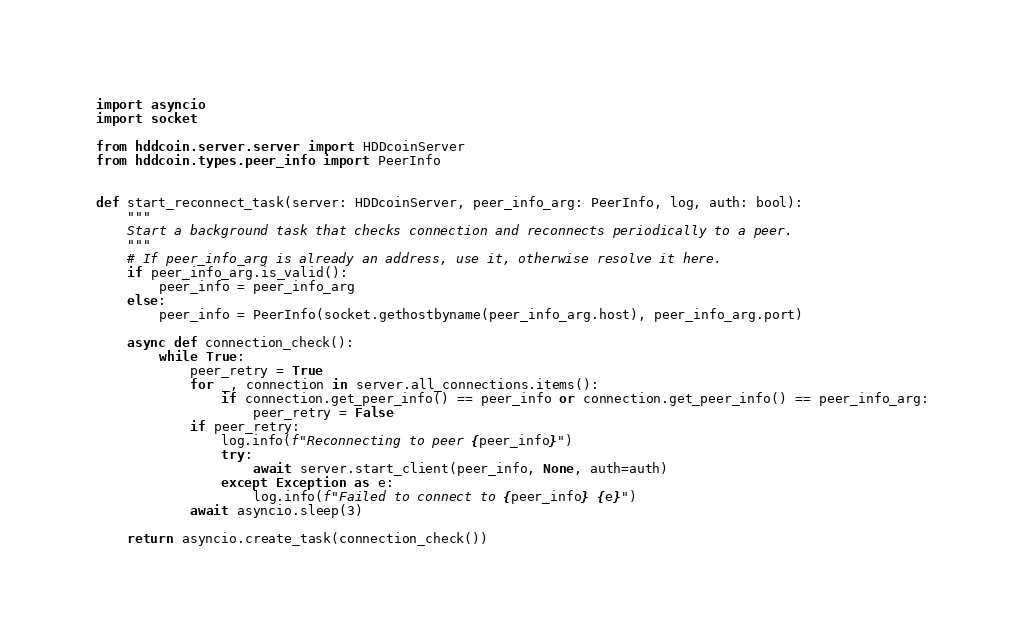<code> <loc_0><loc_0><loc_500><loc_500><_Python_>import asyncio
import socket

from hddcoin.server.server import HDDcoinServer
from hddcoin.types.peer_info import PeerInfo


def start_reconnect_task(server: HDDcoinServer, peer_info_arg: PeerInfo, log, auth: bool):
    """
    Start a background task that checks connection and reconnects periodically to a peer.
    """
    # If peer_info_arg is already an address, use it, otherwise resolve it here.
    if peer_info_arg.is_valid():
        peer_info = peer_info_arg
    else:
        peer_info = PeerInfo(socket.gethostbyname(peer_info_arg.host), peer_info_arg.port)

    async def connection_check():
        while True:
            peer_retry = True
            for _, connection in server.all_connections.items():
                if connection.get_peer_info() == peer_info or connection.get_peer_info() == peer_info_arg:
                    peer_retry = False
            if peer_retry:
                log.info(f"Reconnecting to peer {peer_info}")
                try:
                    await server.start_client(peer_info, None, auth=auth)
                except Exception as e:
                    log.info(f"Failed to connect to {peer_info} {e}")
            await asyncio.sleep(3)

    return asyncio.create_task(connection_check())
</code> 